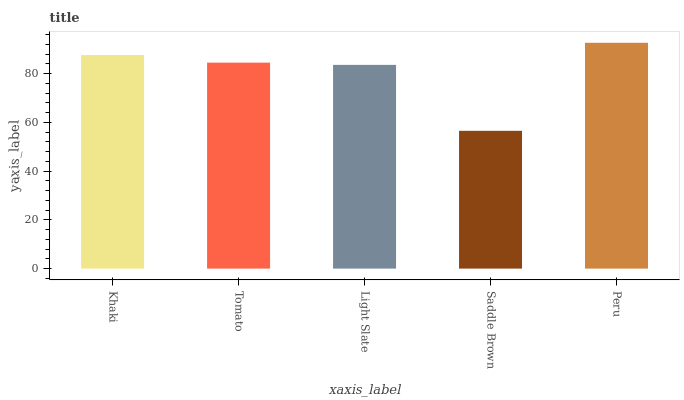Is Saddle Brown the minimum?
Answer yes or no. Yes. Is Peru the maximum?
Answer yes or no. Yes. Is Tomato the minimum?
Answer yes or no. No. Is Tomato the maximum?
Answer yes or no. No. Is Khaki greater than Tomato?
Answer yes or no. Yes. Is Tomato less than Khaki?
Answer yes or no. Yes. Is Tomato greater than Khaki?
Answer yes or no. No. Is Khaki less than Tomato?
Answer yes or no. No. Is Tomato the high median?
Answer yes or no. Yes. Is Tomato the low median?
Answer yes or no. Yes. Is Khaki the high median?
Answer yes or no. No. Is Khaki the low median?
Answer yes or no. No. 